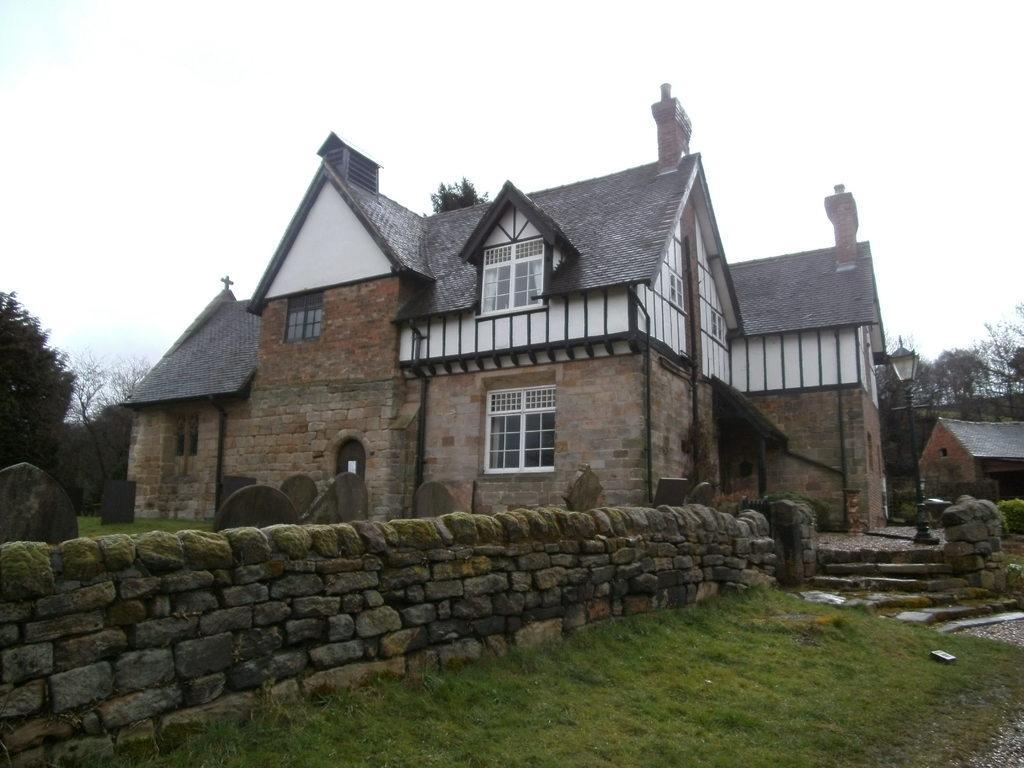Describe this image in one or two sentences. This picture consists of house , on top of house sculpture visible , in front of the house there is the wall , pole and light attached to the pole and on the right side I can see tree and small house, there is the sky on the right side and there are few trees visible on the left side. 